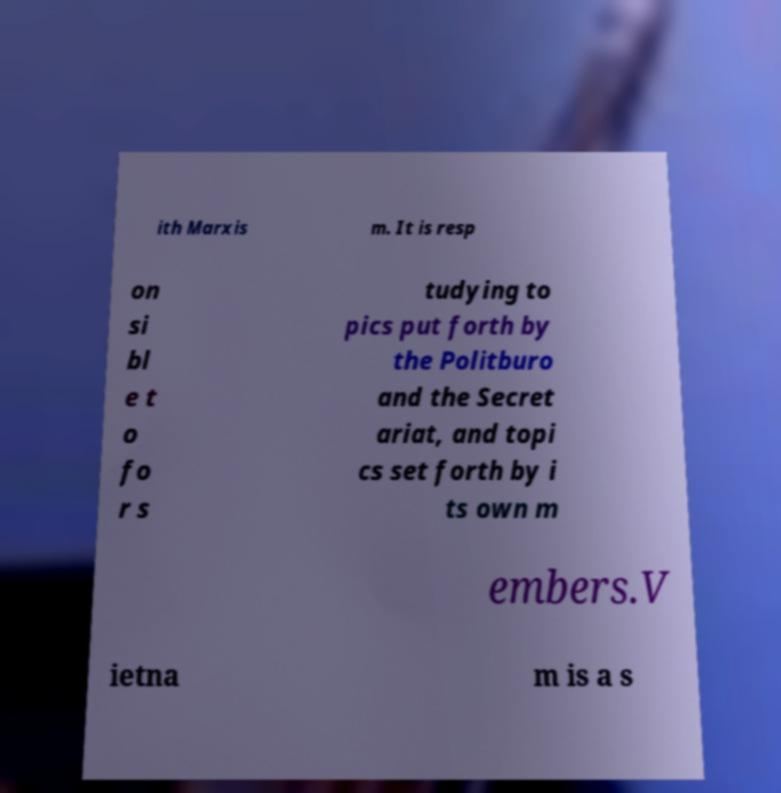Could you extract and type out the text from this image? ith Marxis m. It is resp on si bl e t o fo r s tudying to pics put forth by the Politburo and the Secret ariat, and topi cs set forth by i ts own m embers.V ietna m is a s 